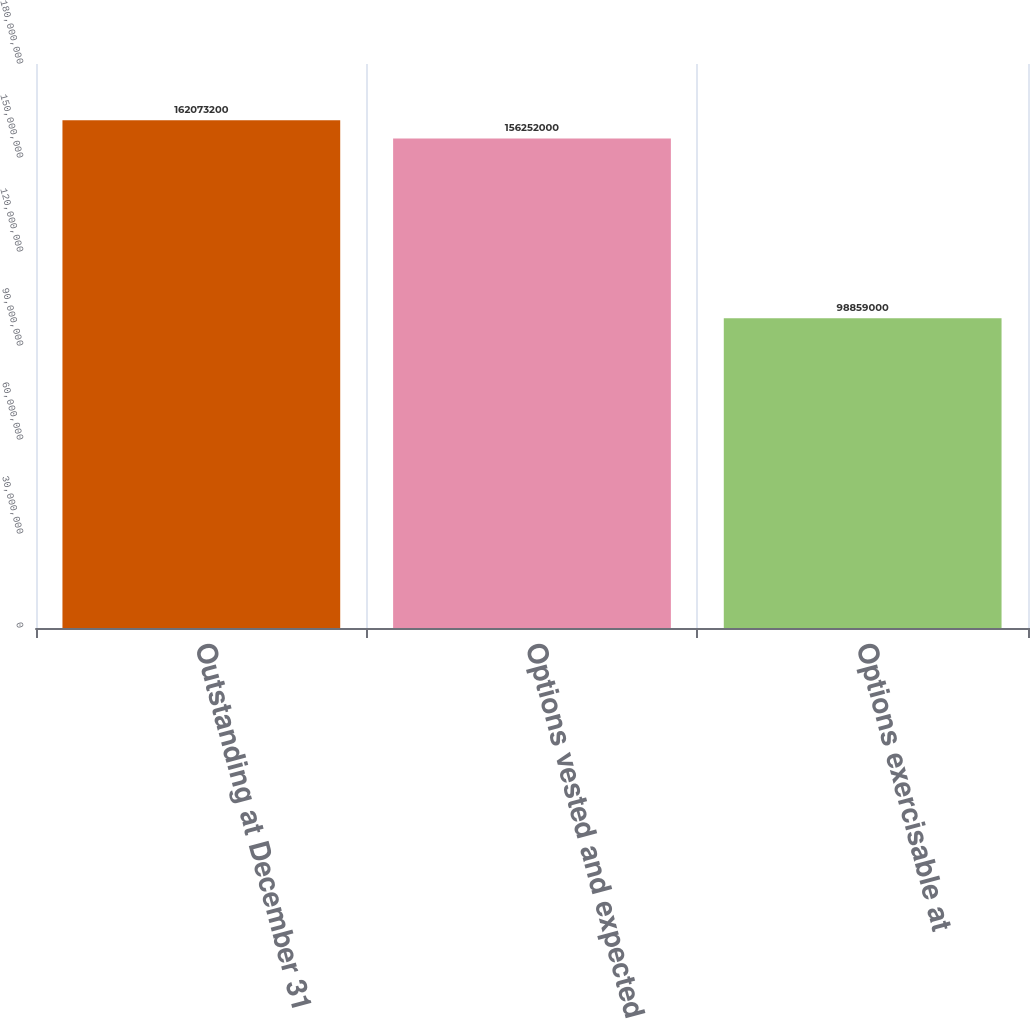Convert chart. <chart><loc_0><loc_0><loc_500><loc_500><bar_chart><fcel>Outstanding at December 31<fcel>Options vested and expected to<fcel>Options exercisable at<nl><fcel>1.62073e+08<fcel>1.56252e+08<fcel>9.8859e+07<nl></chart> 